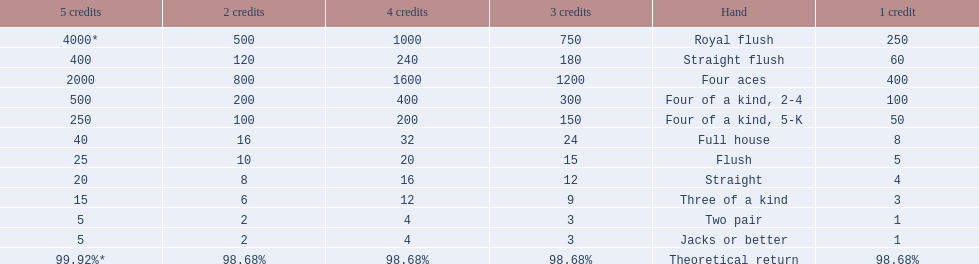What is the values in the 5 credits area? 4000*, 400, 2000, 500, 250, 40, 25, 20, 15, 5, 5. Which of these is for a four of a kind? 500, 250. What is the higher value? 500. What hand is this for Four of a kind, 2-4. 